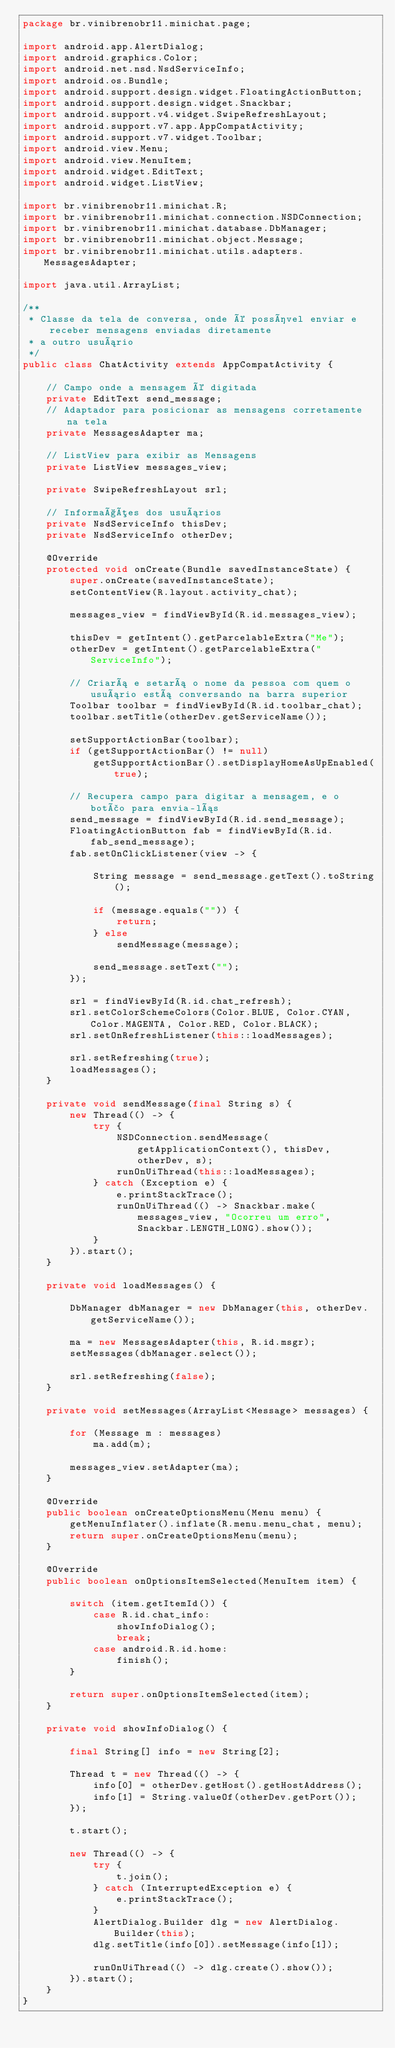<code> <loc_0><loc_0><loc_500><loc_500><_Java_>package br.vinibrenobr11.minichat.page;

import android.app.AlertDialog;
import android.graphics.Color;
import android.net.nsd.NsdServiceInfo;
import android.os.Bundle;
import android.support.design.widget.FloatingActionButton;
import android.support.design.widget.Snackbar;
import android.support.v4.widget.SwipeRefreshLayout;
import android.support.v7.app.AppCompatActivity;
import android.support.v7.widget.Toolbar;
import android.view.Menu;
import android.view.MenuItem;
import android.widget.EditText;
import android.widget.ListView;

import br.vinibrenobr11.minichat.R;
import br.vinibrenobr11.minichat.connection.NSDConnection;
import br.vinibrenobr11.minichat.database.DbManager;
import br.vinibrenobr11.minichat.object.Message;
import br.vinibrenobr11.minichat.utils.adapters.MessagesAdapter;

import java.util.ArrayList;

/**
 * Classe da tela de conversa, onde é possível enviar e receber mensagens enviadas diretamente
 * a outro usuário
 */
public class ChatActivity extends AppCompatActivity {

    // Campo onde a mensagem é digitada
    private EditText send_message;
    // Adaptador para posicionar as mensagens corretamente na tela
    private MessagesAdapter ma;

    // ListView para exibir as Mensagens
    private ListView messages_view;

    private SwipeRefreshLayout srl;

    // Informações dos usuários
    private NsdServiceInfo thisDev;
    private NsdServiceInfo otherDev;

    @Override
    protected void onCreate(Bundle savedInstanceState) {
        super.onCreate(savedInstanceState);
        setContentView(R.layout.activity_chat);

        messages_view = findViewById(R.id.messages_view);

        thisDev = getIntent().getParcelableExtra("Me");
        otherDev = getIntent().getParcelableExtra("ServiceInfo");

        // Criará e setará o nome da pessoa com quem o usuário está conversando na barra superior
        Toolbar toolbar = findViewById(R.id.toolbar_chat);
        toolbar.setTitle(otherDev.getServiceName());

        setSupportActionBar(toolbar);
        if (getSupportActionBar() != null)
            getSupportActionBar().setDisplayHomeAsUpEnabled(true);

        // Recupera campo para digitar a mensagem, e o botão para envia-lás
        send_message = findViewById(R.id.send_message);
        FloatingActionButton fab = findViewById(R.id.fab_send_message);
        fab.setOnClickListener(view -> {

            String message = send_message.getText().toString();

            if (message.equals("")) {
                return;
            } else
                sendMessage(message);

            send_message.setText("");
        });

        srl = findViewById(R.id.chat_refresh);
        srl.setColorSchemeColors(Color.BLUE, Color.CYAN, Color.MAGENTA, Color.RED, Color.BLACK);
        srl.setOnRefreshListener(this::loadMessages);

        srl.setRefreshing(true);
        loadMessages();
    }

    private void sendMessage(final String s) {
        new Thread(() -> {
            try {
                NSDConnection.sendMessage(getApplicationContext(), thisDev, otherDev, s);
                runOnUiThread(this::loadMessages);
            } catch (Exception e) {
                e.printStackTrace();
                runOnUiThread(() -> Snackbar.make(messages_view, "Ocorreu um erro", Snackbar.LENGTH_LONG).show());
            }
        }).start();
    }

    private void loadMessages() {

        DbManager dbManager = new DbManager(this, otherDev.getServiceName());

        ma = new MessagesAdapter(this, R.id.msgr);
        setMessages(dbManager.select());

        srl.setRefreshing(false);
    }

    private void setMessages(ArrayList<Message> messages) {

        for (Message m : messages)
            ma.add(m);

        messages_view.setAdapter(ma);
    }

    @Override
    public boolean onCreateOptionsMenu(Menu menu) {
        getMenuInflater().inflate(R.menu.menu_chat, menu);
        return super.onCreateOptionsMenu(menu);
    }

    @Override
    public boolean onOptionsItemSelected(MenuItem item) {

        switch (item.getItemId()) {
            case R.id.chat_info:
                showInfoDialog();
                break;
            case android.R.id.home:
                finish();
        }

        return super.onOptionsItemSelected(item);
    }

    private void showInfoDialog() {

        final String[] info = new String[2];

        Thread t = new Thread(() -> {
            info[0] = otherDev.getHost().getHostAddress();
            info[1] = String.valueOf(otherDev.getPort());
        });

        t.start();

        new Thread(() -> {
            try {
                t.join();
            } catch (InterruptedException e) {
                e.printStackTrace();
            }
            AlertDialog.Builder dlg = new AlertDialog.Builder(this);
            dlg.setTitle(info[0]).setMessage(info[1]);

            runOnUiThread(() -> dlg.create().show());
        }).start();
    }
}</code> 